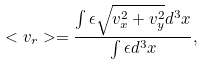<formula> <loc_0><loc_0><loc_500><loc_500>< v _ { r } > = \frac { \int \epsilon \sqrt { v _ { x } ^ { 2 } + v _ { y } ^ { 2 } } d ^ { 3 } x } { \int \epsilon d ^ { 3 } x } ,</formula> 